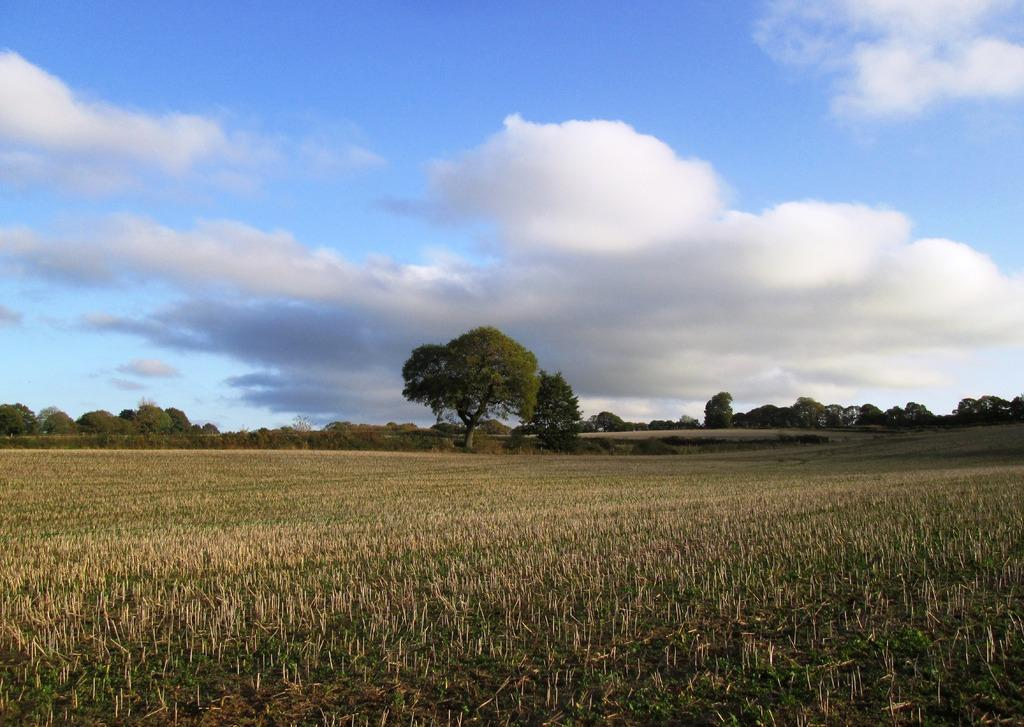What is the main subject in the foreground of the image? There is a farming field in the foreground of the image. What can be seen in the background of the image? There are trees and the sky visible in the background of the image. What is the condition of the sky in the image? The sky is visible in the background of the image, and there are clouds present. What does the son regret in the image? There is no son or any indication of regret present in the image. 